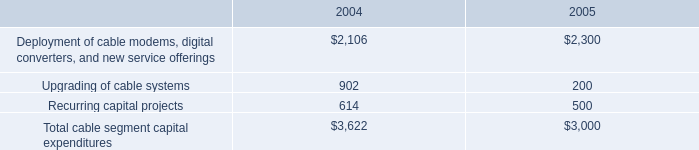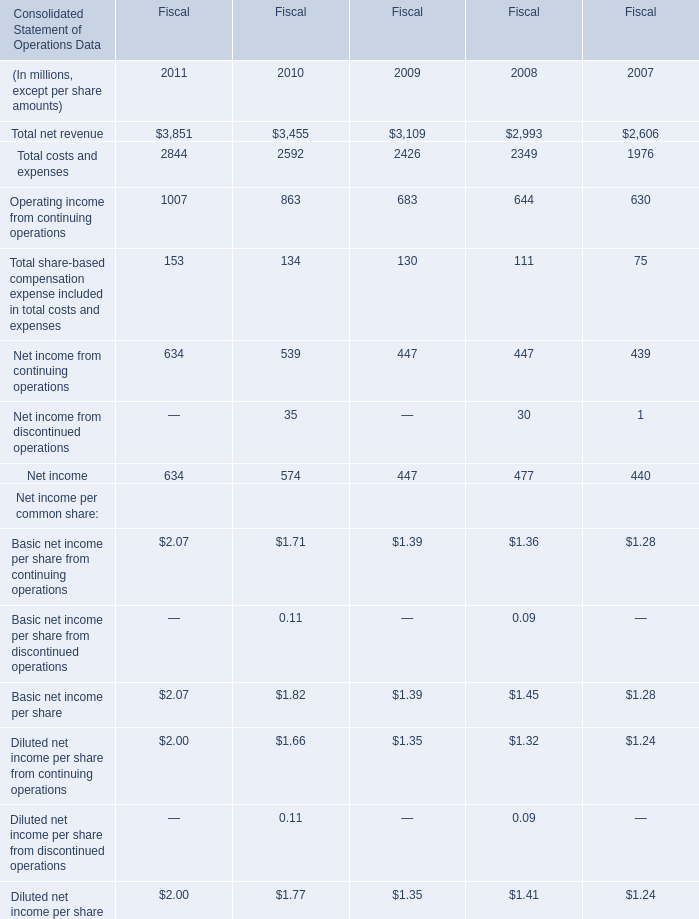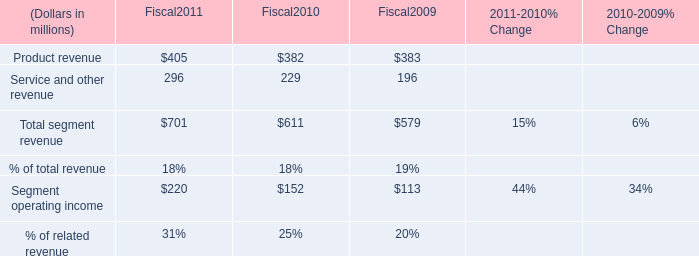What's the growth rate of Net income in Fiscal 2010? 
Computations: ((574 - 447) / 447)
Answer: 0.28412. 